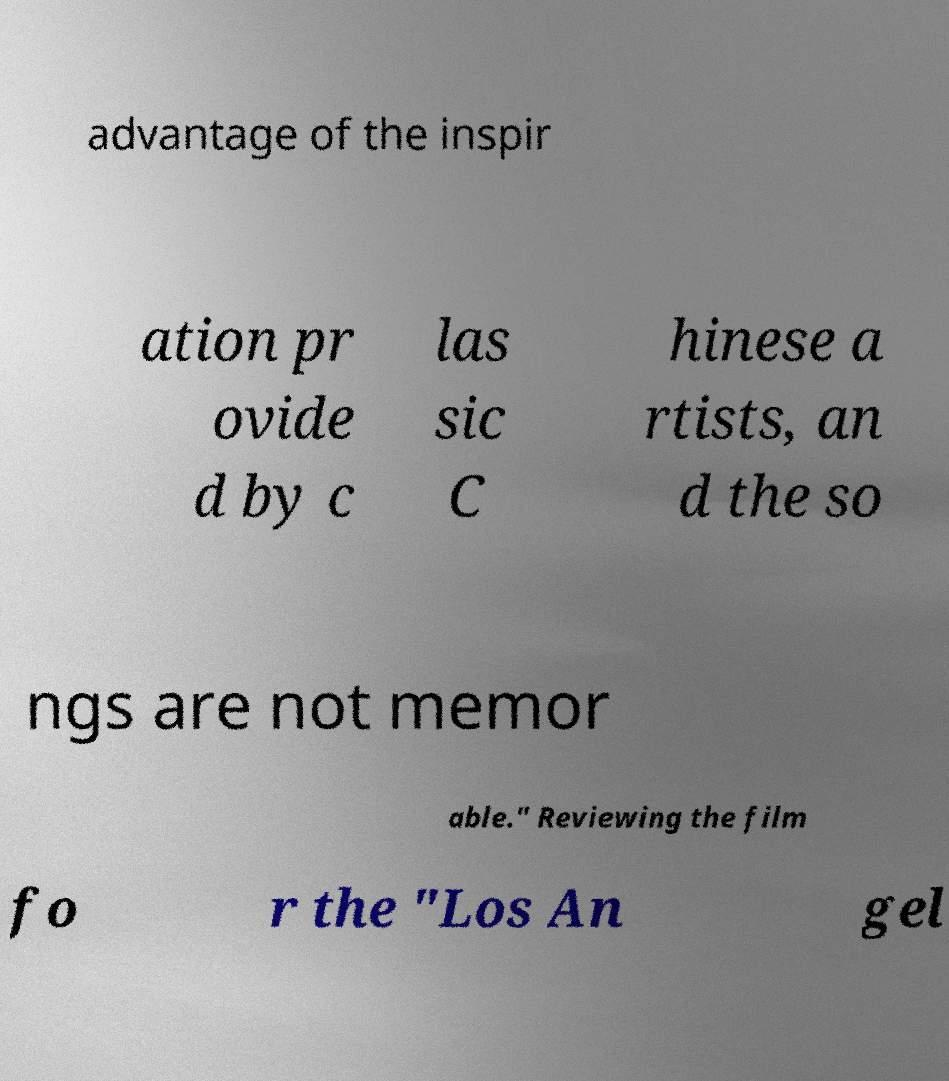Could you assist in decoding the text presented in this image and type it out clearly? advantage of the inspir ation pr ovide d by c las sic C hinese a rtists, an d the so ngs are not memor able." Reviewing the film fo r the "Los An gel 